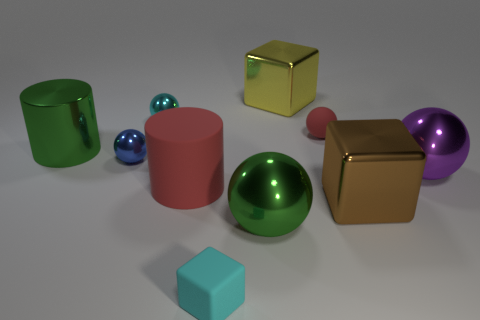There is a metal thing that is the same color as the small rubber block; what shape is it?
Provide a succinct answer. Sphere. There is a object that is the same color as the small block; what is its size?
Your response must be concise. Small. What is the material of the small cyan thing behind the metallic object that is in front of the big brown thing?
Make the answer very short. Metal. Is there anything else that has the same size as the red matte sphere?
Offer a terse response. Yes. Are the cyan block and the small ball that is to the right of the yellow shiny block made of the same material?
Keep it short and to the point. Yes. There is a block that is both in front of the tiny blue metallic ball and behind the cyan cube; what is it made of?
Your answer should be compact. Metal. There is a big block that is in front of the large object that is behind the matte ball; what color is it?
Your answer should be compact. Brown. There is a large red object that is in front of the small blue metallic thing; what is it made of?
Ensure brevity in your answer.  Rubber. Is the number of large shiny cylinders less than the number of small yellow cylinders?
Offer a very short reply. No. There is a small red matte object; does it have the same shape as the cyan object in front of the cyan shiny object?
Your answer should be compact. No. 